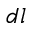Convert formula to latex. <formula><loc_0><loc_0><loc_500><loc_500>d l</formula> 